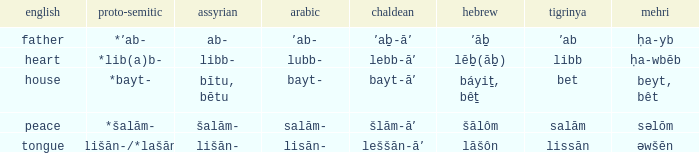If in English it's house, what is it in proto-semitic? *bayt-. 